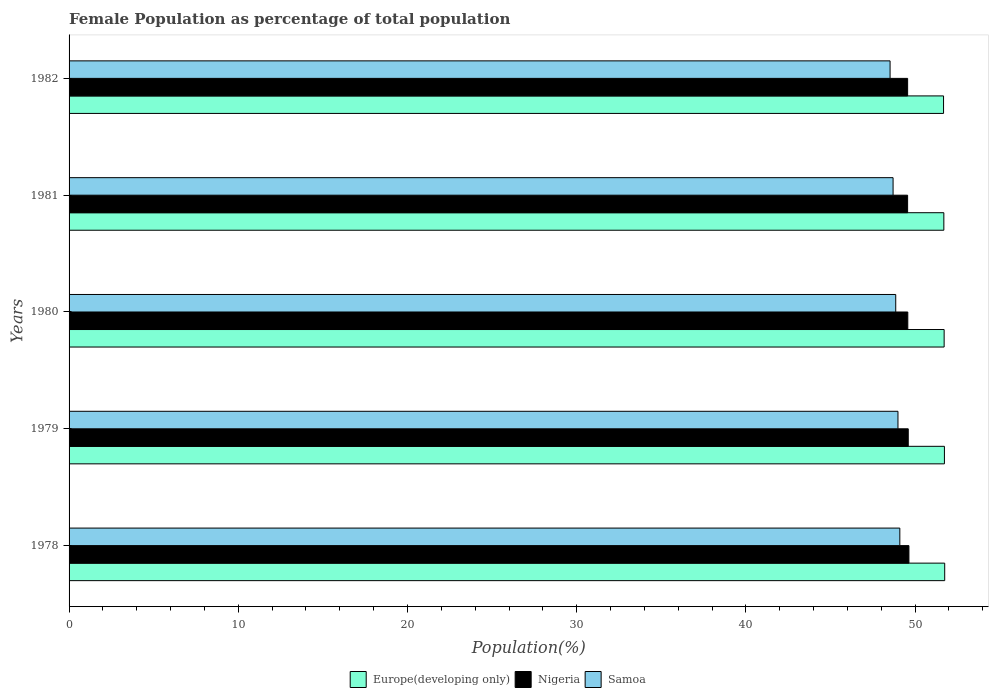How many different coloured bars are there?
Provide a succinct answer. 3. Are the number of bars per tick equal to the number of legend labels?
Give a very brief answer. Yes. How many bars are there on the 5th tick from the top?
Your answer should be very brief. 3. In how many cases, is the number of bars for a given year not equal to the number of legend labels?
Your answer should be very brief. 0. What is the female population in in Europe(developing only) in 1981?
Your answer should be very brief. 51.7. Across all years, what is the maximum female population in in Nigeria?
Ensure brevity in your answer.  49.64. Across all years, what is the minimum female population in in Europe(developing only)?
Your response must be concise. 51.68. In which year was the female population in in Samoa maximum?
Your answer should be compact. 1978. What is the total female population in in Samoa in the graph?
Offer a very short reply. 244.17. What is the difference between the female population in in Nigeria in 1978 and that in 1981?
Make the answer very short. 0.08. What is the difference between the female population in in Samoa in 1981 and the female population in in Nigeria in 1980?
Provide a short and direct response. -0.87. What is the average female population in in Europe(developing only) per year?
Provide a succinct answer. 51.72. In the year 1980, what is the difference between the female population in in Samoa and female population in in Nigeria?
Provide a succinct answer. -0.71. In how many years, is the female population in in Nigeria greater than 34 %?
Your answer should be very brief. 5. What is the ratio of the female population in in Samoa in 1978 to that in 1980?
Keep it short and to the point. 1. Is the female population in in Nigeria in 1979 less than that in 1980?
Provide a succinct answer. No. What is the difference between the highest and the second highest female population in in Europe(developing only)?
Offer a terse response. 0.02. What is the difference between the highest and the lowest female population in in Samoa?
Offer a terse response. 0.58. In how many years, is the female population in in Europe(developing only) greater than the average female population in in Europe(developing only) taken over all years?
Keep it short and to the point. 3. Is the sum of the female population in in Europe(developing only) in 1978 and 1981 greater than the maximum female population in in Samoa across all years?
Offer a very short reply. Yes. What does the 2nd bar from the top in 1981 represents?
Your response must be concise. Nigeria. What does the 2nd bar from the bottom in 1979 represents?
Offer a very short reply. Nigeria. What is the difference between two consecutive major ticks on the X-axis?
Provide a succinct answer. 10. Does the graph contain any zero values?
Your answer should be very brief. No. Where does the legend appear in the graph?
Keep it short and to the point. Bottom center. What is the title of the graph?
Offer a very short reply. Female Population as percentage of total population. Does "Burundi" appear as one of the legend labels in the graph?
Provide a short and direct response. No. What is the label or title of the X-axis?
Your answer should be very brief. Population(%). What is the label or title of the Y-axis?
Keep it short and to the point. Years. What is the Population(%) of Europe(developing only) in 1978?
Your answer should be compact. 51.75. What is the Population(%) of Nigeria in 1978?
Ensure brevity in your answer.  49.64. What is the Population(%) of Samoa in 1978?
Provide a short and direct response. 49.1. What is the Population(%) in Europe(developing only) in 1979?
Your response must be concise. 51.73. What is the Population(%) in Nigeria in 1979?
Provide a succinct answer. 49.6. What is the Population(%) of Samoa in 1979?
Offer a very short reply. 48.99. What is the Population(%) of Europe(developing only) in 1980?
Make the answer very short. 51.72. What is the Population(%) in Nigeria in 1980?
Provide a succinct answer. 49.57. What is the Population(%) in Samoa in 1980?
Your answer should be very brief. 48.86. What is the Population(%) in Europe(developing only) in 1981?
Give a very brief answer. 51.7. What is the Population(%) of Nigeria in 1981?
Ensure brevity in your answer.  49.56. What is the Population(%) of Samoa in 1981?
Keep it short and to the point. 48.7. What is the Population(%) in Europe(developing only) in 1982?
Make the answer very short. 51.68. What is the Population(%) in Nigeria in 1982?
Your answer should be very brief. 49.56. What is the Population(%) of Samoa in 1982?
Offer a terse response. 48.52. Across all years, what is the maximum Population(%) in Europe(developing only)?
Ensure brevity in your answer.  51.75. Across all years, what is the maximum Population(%) in Nigeria?
Make the answer very short. 49.64. Across all years, what is the maximum Population(%) in Samoa?
Your answer should be compact. 49.1. Across all years, what is the minimum Population(%) in Europe(developing only)?
Offer a very short reply. 51.68. Across all years, what is the minimum Population(%) in Nigeria?
Provide a succinct answer. 49.56. Across all years, what is the minimum Population(%) in Samoa?
Your response must be concise. 48.52. What is the total Population(%) of Europe(developing only) in the graph?
Provide a succinct answer. 258.59. What is the total Population(%) in Nigeria in the graph?
Your answer should be very brief. 247.92. What is the total Population(%) in Samoa in the graph?
Your answer should be compact. 244.17. What is the difference between the Population(%) of Europe(developing only) in 1978 and that in 1979?
Your answer should be very brief. 0.02. What is the difference between the Population(%) of Nigeria in 1978 and that in 1979?
Provide a short and direct response. 0.04. What is the difference between the Population(%) in Samoa in 1978 and that in 1979?
Your answer should be compact. 0.11. What is the difference between the Population(%) in Europe(developing only) in 1978 and that in 1980?
Offer a terse response. 0.03. What is the difference between the Population(%) of Nigeria in 1978 and that in 1980?
Your answer should be very brief. 0.07. What is the difference between the Population(%) in Samoa in 1978 and that in 1980?
Provide a succinct answer. 0.24. What is the difference between the Population(%) in Europe(developing only) in 1978 and that in 1981?
Your answer should be compact. 0.05. What is the difference between the Population(%) of Nigeria in 1978 and that in 1981?
Your response must be concise. 0.08. What is the difference between the Population(%) in Samoa in 1978 and that in 1981?
Make the answer very short. 0.4. What is the difference between the Population(%) of Europe(developing only) in 1978 and that in 1982?
Make the answer very short. 0.07. What is the difference between the Population(%) of Nigeria in 1978 and that in 1982?
Offer a terse response. 0.08. What is the difference between the Population(%) of Samoa in 1978 and that in 1982?
Provide a short and direct response. 0.58. What is the difference between the Population(%) in Europe(developing only) in 1979 and that in 1980?
Your answer should be very brief. 0.02. What is the difference between the Population(%) in Nigeria in 1979 and that in 1980?
Keep it short and to the point. 0.03. What is the difference between the Population(%) of Samoa in 1979 and that in 1980?
Give a very brief answer. 0.13. What is the difference between the Population(%) in Europe(developing only) in 1979 and that in 1981?
Give a very brief answer. 0.03. What is the difference between the Population(%) in Nigeria in 1979 and that in 1981?
Your answer should be compact. 0.04. What is the difference between the Population(%) of Samoa in 1979 and that in 1981?
Give a very brief answer. 0.29. What is the difference between the Population(%) of Europe(developing only) in 1979 and that in 1982?
Keep it short and to the point. 0.05. What is the difference between the Population(%) of Nigeria in 1979 and that in 1982?
Provide a succinct answer. 0.04. What is the difference between the Population(%) in Samoa in 1979 and that in 1982?
Your answer should be very brief. 0.47. What is the difference between the Population(%) of Europe(developing only) in 1980 and that in 1981?
Provide a short and direct response. 0.02. What is the difference between the Population(%) of Nigeria in 1980 and that in 1981?
Your answer should be very brief. 0.01. What is the difference between the Population(%) of Samoa in 1980 and that in 1981?
Your answer should be compact. 0.16. What is the difference between the Population(%) of Europe(developing only) in 1980 and that in 1982?
Provide a short and direct response. 0.03. What is the difference between the Population(%) of Nigeria in 1980 and that in 1982?
Provide a short and direct response. 0.01. What is the difference between the Population(%) in Samoa in 1980 and that in 1982?
Make the answer very short. 0.33. What is the difference between the Population(%) of Europe(developing only) in 1981 and that in 1982?
Provide a succinct answer. 0.02. What is the difference between the Population(%) of Nigeria in 1981 and that in 1982?
Keep it short and to the point. -0. What is the difference between the Population(%) of Samoa in 1981 and that in 1982?
Make the answer very short. 0.18. What is the difference between the Population(%) in Europe(developing only) in 1978 and the Population(%) in Nigeria in 1979?
Offer a terse response. 2.16. What is the difference between the Population(%) in Europe(developing only) in 1978 and the Population(%) in Samoa in 1979?
Provide a succinct answer. 2.76. What is the difference between the Population(%) in Nigeria in 1978 and the Population(%) in Samoa in 1979?
Give a very brief answer. 0.65. What is the difference between the Population(%) of Europe(developing only) in 1978 and the Population(%) of Nigeria in 1980?
Your answer should be compact. 2.18. What is the difference between the Population(%) of Europe(developing only) in 1978 and the Population(%) of Samoa in 1980?
Ensure brevity in your answer.  2.89. What is the difference between the Population(%) in Nigeria in 1978 and the Population(%) in Samoa in 1980?
Provide a short and direct response. 0.78. What is the difference between the Population(%) in Europe(developing only) in 1978 and the Population(%) in Nigeria in 1981?
Make the answer very short. 2.19. What is the difference between the Population(%) in Europe(developing only) in 1978 and the Population(%) in Samoa in 1981?
Make the answer very short. 3.05. What is the difference between the Population(%) of Nigeria in 1978 and the Population(%) of Samoa in 1981?
Provide a succinct answer. 0.94. What is the difference between the Population(%) in Europe(developing only) in 1978 and the Population(%) in Nigeria in 1982?
Ensure brevity in your answer.  2.19. What is the difference between the Population(%) in Europe(developing only) in 1978 and the Population(%) in Samoa in 1982?
Ensure brevity in your answer.  3.23. What is the difference between the Population(%) in Nigeria in 1978 and the Population(%) in Samoa in 1982?
Offer a terse response. 1.11. What is the difference between the Population(%) in Europe(developing only) in 1979 and the Population(%) in Nigeria in 1980?
Give a very brief answer. 2.16. What is the difference between the Population(%) of Europe(developing only) in 1979 and the Population(%) of Samoa in 1980?
Make the answer very short. 2.88. What is the difference between the Population(%) of Nigeria in 1979 and the Population(%) of Samoa in 1980?
Your answer should be very brief. 0.74. What is the difference between the Population(%) in Europe(developing only) in 1979 and the Population(%) in Nigeria in 1981?
Provide a succinct answer. 2.18. What is the difference between the Population(%) in Europe(developing only) in 1979 and the Population(%) in Samoa in 1981?
Offer a terse response. 3.04. What is the difference between the Population(%) in Nigeria in 1979 and the Population(%) in Samoa in 1981?
Make the answer very short. 0.9. What is the difference between the Population(%) in Europe(developing only) in 1979 and the Population(%) in Nigeria in 1982?
Your answer should be very brief. 2.18. What is the difference between the Population(%) in Europe(developing only) in 1979 and the Population(%) in Samoa in 1982?
Give a very brief answer. 3.21. What is the difference between the Population(%) in Nigeria in 1979 and the Population(%) in Samoa in 1982?
Provide a short and direct response. 1.07. What is the difference between the Population(%) of Europe(developing only) in 1980 and the Population(%) of Nigeria in 1981?
Your answer should be very brief. 2.16. What is the difference between the Population(%) in Europe(developing only) in 1980 and the Population(%) in Samoa in 1981?
Your answer should be very brief. 3.02. What is the difference between the Population(%) in Nigeria in 1980 and the Population(%) in Samoa in 1981?
Make the answer very short. 0.87. What is the difference between the Population(%) of Europe(developing only) in 1980 and the Population(%) of Nigeria in 1982?
Ensure brevity in your answer.  2.16. What is the difference between the Population(%) in Europe(developing only) in 1980 and the Population(%) in Samoa in 1982?
Your response must be concise. 3.19. What is the difference between the Population(%) in Nigeria in 1980 and the Population(%) in Samoa in 1982?
Make the answer very short. 1.05. What is the difference between the Population(%) in Europe(developing only) in 1981 and the Population(%) in Nigeria in 1982?
Offer a very short reply. 2.14. What is the difference between the Population(%) of Europe(developing only) in 1981 and the Population(%) of Samoa in 1982?
Ensure brevity in your answer.  3.18. What is the difference between the Population(%) in Nigeria in 1981 and the Population(%) in Samoa in 1982?
Your answer should be compact. 1.04. What is the average Population(%) of Europe(developing only) per year?
Offer a very short reply. 51.72. What is the average Population(%) of Nigeria per year?
Offer a very short reply. 49.58. What is the average Population(%) in Samoa per year?
Your response must be concise. 48.83. In the year 1978, what is the difference between the Population(%) in Europe(developing only) and Population(%) in Nigeria?
Ensure brevity in your answer.  2.11. In the year 1978, what is the difference between the Population(%) of Europe(developing only) and Population(%) of Samoa?
Provide a short and direct response. 2.65. In the year 1978, what is the difference between the Population(%) in Nigeria and Population(%) in Samoa?
Keep it short and to the point. 0.54. In the year 1979, what is the difference between the Population(%) in Europe(developing only) and Population(%) in Nigeria?
Offer a very short reply. 2.14. In the year 1979, what is the difference between the Population(%) in Europe(developing only) and Population(%) in Samoa?
Give a very brief answer. 2.75. In the year 1979, what is the difference between the Population(%) in Nigeria and Population(%) in Samoa?
Your answer should be compact. 0.61. In the year 1980, what is the difference between the Population(%) in Europe(developing only) and Population(%) in Nigeria?
Keep it short and to the point. 2.15. In the year 1980, what is the difference between the Population(%) in Europe(developing only) and Population(%) in Samoa?
Your answer should be very brief. 2.86. In the year 1980, what is the difference between the Population(%) of Nigeria and Population(%) of Samoa?
Your answer should be very brief. 0.71. In the year 1981, what is the difference between the Population(%) in Europe(developing only) and Population(%) in Nigeria?
Your response must be concise. 2.14. In the year 1981, what is the difference between the Population(%) of Europe(developing only) and Population(%) of Samoa?
Keep it short and to the point. 3. In the year 1981, what is the difference between the Population(%) of Nigeria and Population(%) of Samoa?
Keep it short and to the point. 0.86. In the year 1982, what is the difference between the Population(%) in Europe(developing only) and Population(%) in Nigeria?
Make the answer very short. 2.12. In the year 1982, what is the difference between the Population(%) in Europe(developing only) and Population(%) in Samoa?
Your response must be concise. 3.16. In the year 1982, what is the difference between the Population(%) of Nigeria and Population(%) of Samoa?
Ensure brevity in your answer.  1.04. What is the ratio of the Population(%) in Europe(developing only) in 1978 to that in 1979?
Give a very brief answer. 1. What is the ratio of the Population(%) of Nigeria in 1978 to that in 1979?
Keep it short and to the point. 1. What is the ratio of the Population(%) of Samoa in 1978 to that in 1979?
Offer a very short reply. 1. What is the ratio of the Population(%) in Europe(developing only) in 1978 to that in 1980?
Offer a very short reply. 1. What is the ratio of the Population(%) of Nigeria in 1978 to that in 1980?
Your response must be concise. 1. What is the ratio of the Population(%) in Samoa in 1978 to that in 1980?
Your answer should be compact. 1. What is the ratio of the Population(%) in Europe(developing only) in 1978 to that in 1981?
Your answer should be very brief. 1. What is the ratio of the Population(%) in Samoa in 1978 to that in 1981?
Ensure brevity in your answer.  1.01. What is the ratio of the Population(%) in Nigeria in 1978 to that in 1982?
Offer a very short reply. 1. What is the ratio of the Population(%) in Samoa in 1978 to that in 1982?
Your answer should be compact. 1.01. What is the ratio of the Population(%) of Nigeria in 1979 to that in 1980?
Your answer should be compact. 1. What is the ratio of the Population(%) of Samoa in 1979 to that in 1980?
Your answer should be very brief. 1. What is the ratio of the Population(%) in Samoa in 1979 to that in 1981?
Provide a succinct answer. 1.01. What is the ratio of the Population(%) in Nigeria in 1979 to that in 1982?
Keep it short and to the point. 1. What is the ratio of the Population(%) of Samoa in 1979 to that in 1982?
Offer a very short reply. 1.01. What is the ratio of the Population(%) in Europe(developing only) in 1980 to that in 1981?
Keep it short and to the point. 1. What is the ratio of the Population(%) in Nigeria in 1980 to that in 1981?
Provide a short and direct response. 1. What is the ratio of the Population(%) of Europe(developing only) in 1980 to that in 1982?
Make the answer very short. 1. What is the ratio of the Population(%) in Nigeria in 1980 to that in 1982?
Your answer should be very brief. 1. What is the difference between the highest and the second highest Population(%) of Europe(developing only)?
Give a very brief answer. 0.02. What is the difference between the highest and the second highest Population(%) in Nigeria?
Your answer should be compact. 0.04. What is the difference between the highest and the second highest Population(%) in Samoa?
Make the answer very short. 0.11. What is the difference between the highest and the lowest Population(%) of Europe(developing only)?
Provide a succinct answer. 0.07. What is the difference between the highest and the lowest Population(%) of Nigeria?
Your answer should be compact. 0.08. What is the difference between the highest and the lowest Population(%) in Samoa?
Make the answer very short. 0.58. 